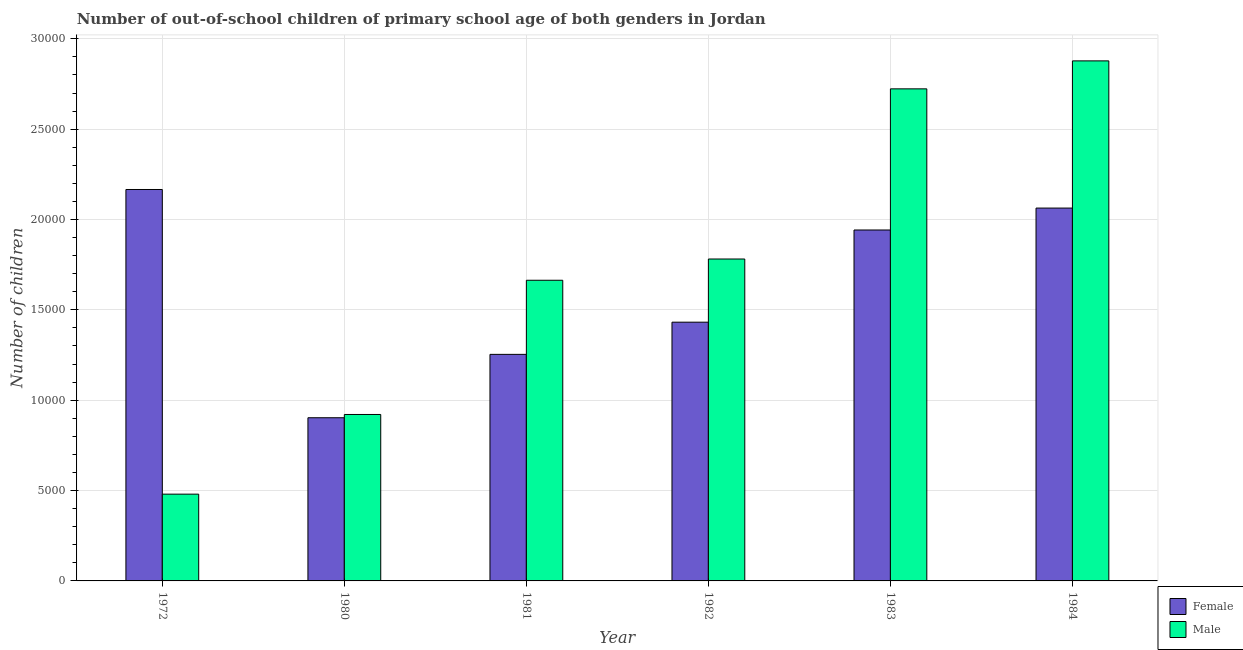How many different coloured bars are there?
Provide a short and direct response. 2. Are the number of bars per tick equal to the number of legend labels?
Your response must be concise. Yes. How many bars are there on the 1st tick from the left?
Offer a very short reply. 2. What is the label of the 5th group of bars from the left?
Your response must be concise. 1983. In how many cases, is the number of bars for a given year not equal to the number of legend labels?
Ensure brevity in your answer.  0. What is the number of female out-of-school students in 1972?
Keep it short and to the point. 2.17e+04. Across all years, what is the maximum number of male out-of-school students?
Provide a succinct answer. 2.88e+04. Across all years, what is the minimum number of female out-of-school students?
Keep it short and to the point. 9030. In which year was the number of female out-of-school students maximum?
Provide a succinct answer. 1972. In which year was the number of male out-of-school students minimum?
Your response must be concise. 1972. What is the total number of male out-of-school students in the graph?
Your response must be concise. 1.04e+05. What is the difference between the number of male out-of-school students in 1982 and that in 1984?
Offer a terse response. -1.10e+04. What is the difference between the number of female out-of-school students in 1982 and the number of male out-of-school students in 1980?
Your answer should be very brief. 5288. What is the average number of female out-of-school students per year?
Give a very brief answer. 1.63e+04. In the year 1981, what is the difference between the number of female out-of-school students and number of male out-of-school students?
Your answer should be compact. 0. What is the ratio of the number of female out-of-school students in 1981 to that in 1982?
Your response must be concise. 0.88. Is the difference between the number of male out-of-school students in 1980 and 1981 greater than the difference between the number of female out-of-school students in 1980 and 1981?
Provide a short and direct response. No. What is the difference between the highest and the second highest number of female out-of-school students?
Keep it short and to the point. 1028. What is the difference between the highest and the lowest number of female out-of-school students?
Provide a short and direct response. 1.26e+04. In how many years, is the number of male out-of-school students greater than the average number of male out-of-school students taken over all years?
Give a very brief answer. 3. Is the sum of the number of male out-of-school students in 1981 and 1982 greater than the maximum number of female out-of-school students across all years?
Provide a short and direct response. Yes. What does the 1st bar from the left in 1980 represents?
Ensure brevity in your answer.  Female. How many bars are there?
Give a very brief answer. 12. What is the difference between two consecutive major ticks on the Y-axis?
Your answer should be compact. 5000. Where does the legend appear in the graph?
Give a very brief answer. Bottom right. How many legend labels are there?
Your response must be concise. 2. What is the title of the graph?
Keep it short and to the point. Number of out-of-school children of primary school age of both genders in Jordan. Does "Short-term debt" appear as one of the legend labels in the graph?
Ensure brevity in your answer.  No. What is the label or title of the X-axis?
Keep it short and to the point. Year. What is the label or title of the Y-axis?
Keep it short and to the point. Number of children. What is the Number of children of Female in 1972?
Your response must be concise. 2.17e+04. What is the Number of children of Male in 1972?
Ensure brevity in your answer.  4802. What is the Number of children of Female in 1980?
Your answer should be very brief. 9030. What is the Number of children in Male in 1980?
Your answer should be very brief. 9211. What is the Number of children in Female in 1981?
Offer a terse response. 1.25e+04. What is the Number of children in Male in 1981?
Offer a terse response. 1.66e+04. What is the Number of children of Female in 1982?
Offer a very short reply. 1.43e+04. What is the Number of children in Male in 1982?
Your answer should be very brief. 1.78e+04. What is the Number of children in Female in 1983?
Keep it short and to the point. 1.94e+04. What is the Number of children in Male in 1983?
Your response must be concise. 2.72e+04. What is the Number of children in Female in 1984?
Your response must be concise. 2.06e+04. What is the Number of children in Male in 1984?
Your answer should be compact. 2.88e+04. Across all years, what is the maximum Number of children of Female?
Ensure brevity in your answer.  2.17e+04. Across all years, what is the maximum Number of children of Male?
Keep it short and to the point. 2.88e+04. Across all years, what is the minimum Number of children in Female?
Ensure brevity in your answer.  9030. Across all years, what is the minimum Number of children of Male?
Give a very brief answer. 4802. What is the total Number of children in Female in the graph?
Ensure brevity in your answer.  9.76e+04. What is the total Number of children in Male in the graph?
Provide a succinct answer. 1.04e+05. What is the difference between the Number of children of Female in 1972 and that in 1980?
Give a very brief answer. 1.26e+04. What is the difference between the Number of children in Male in 1972 and that in 1980?
Keep it short and to the point. -4409. What is the difference between the Number of children in Female in 1972 and that in 1981?
Your response must be concise. 9124. What is the difference between the Number of children of Male in 1972 and that in 1981?
Offer a very short reply. -1.18e+04. What is the difference between the Number of children in Female in 1972 and that in 1982?
Ensure brevity in your answer.  7343. What is the difference between the Number of children of Male in 1972 and that in 1982?
Your response must be concise. -1.30e+04. What is the difference between the Number of children in Female in 1972 and that in 1983?
Your answer should be compact. 2241. What is the difference between the Number of children in Male in 1972 and that in 1983?
Your answer should be very brief. -2.24e+04. What is the difference between the Number of children of Female in 1972 and that in 1984?
Your answer should be compact. 1028. What is the difference between the Number of children of Male in 1972 and that in 1984?
Offer a terse response. -2.40e+04. What is the difference between the Number of children in Female in 1980 and that in 1981?
Offer a terse response. -3507. What is the difference between the Number of children of Male in 1980 and that in 1981?
Offer a very short reply. -7427. What is the difference between the Number of children in Female in 1980 and that in 1982?
Give a very brief answer. -5288. What is the difference between the Number of children in Male in 1980 and that in 1982?
Make the answer very short. -8603. What is the difference between the Number of children of Female in 1980 and that in 1983?
Give a very brief answer. -1.04e+04. What is the difference between the Number of children in Male in 1980 and that in 1983?
Provide a short and direct response. -1.80e+04. What is the difference between the Number of children of Female in 1980 and that in 1984?
Your response must be concise. -1.16e+04. What is the difference between the Number of children in Male in 1980 and that in 1984?
Keep it short and to the point. -1.96e+04. What is the difference between the Number of children of Female in 1981 and that in 1982?
Your answer should be compact. -1781. What is the difference between the Number of children in Male in 1981 and that in 1982?
Make the answer very short. -1176. What is the difference between the Number of children in Female in 1981 and that in 1983?
Offer a terse response. -6883. What is the difference between the Number of children of Male in 1981 and that in 1983?
Offer a terse response. -1.06e+04. What is the difference between the Number of children of Female in 1981 and that in 1984?
Your response must be concise. -8096. What is the difference between the Number of children in Male in 1981 and that in 1984?
Offer a terse response. -1.21e+04. What is the difference between the Number of children in Female in 1982 and that in 1983?
Provide a succinct answer. -5102. What is the difference between the Number of children in Male in 1982 and that in 1983?
Give a very brief answer. -9416. What is the difference between the Number of children in Female in 1982 and that in 1984?
Give a very brief answer. -6315. What is the difference between the Number of children in Male in 1982 and that in 1984?
Offer a terse response. -1.10e+04. What is the difference between the Number of children of Female in 1983 and that in 1984?
Give a very brief answer. -1213. What is the difference between the Number of children of Male in 1983 and that in 1984?
Keep it short and to the point. -1548. What is the difference between the Number of children in Female in 1972 and the Number of children in Male in 1980?
Offer a very short reply. 1.24e+04. What is the difference between the Number of children in Female in 1972 and the Number of children in Male in 1981?
Offer a terse response. 5023. What is the difference between the Number of children of Female in 1972 and the Number of children of Male in 1982?
Offer a very short reply. 3847. What is the difference between the Number of children of Female in 1972 and the Number of children of Male in 1983?
Offer a very short reply. -5569. What is the difference between the Number of children in Female in 1972 and the Number of children in Male in 1984?
Your answer should be very brief. -7117. What is the difference between the Number of children of Female in 1980 and the Number of children of Male in 1981?
Keep it short and to the point. -7608. What is the difference between the Number of children of Female in 1980 and the Number of children of Male in 1982?
Ensure brevity in your answer.  -8784. What is the difference between the Number of children in Female in 1980 and the Number of children in Male in 1983?
Give a very brief answer. -1.82e+04. What is the difference between the Number of children of Female in 1980 and the Number of children of Male in 1984?
Your answer should be very brief. -1.97e+04. What is the difference between the Number of children in Female in 1981 and the Number of children in Male in 1982?
Provide a succinct answer. -5277. What is the difference between the Number of children in Female in 1981 and the Number of children in Male in 1983?
Provide a succinct answer. -1.47e+04. What is the difference between the Number of children in Female in 1981 and the Number of children in Male in 1984?
Give a very brief answer. -1.62e+04. What is the difference between the Number of children in Female in 1982 and the Number of children in Male in 1983?
Your answer should be compact. -1.29e+04. What is the difference between the Number of children of Female in 1982 and the Number of children of Male in 1984?
Your answer should be very brief. -1.45e+04. What is the difference between the Number of children in Female in 1983 and the Number of children in Male in 1984?
Ensure brevity in your answer.  -9358. What is the average Number of children of Female per year?
Your answer should be compact. 1.63e+04. What is the average Number of children in Male per year?
Provide a short and direct response. 1.74e+04. In the year 1972, what is the difference between the Number of children of Female and Number of children of Male?
Provide a short and direct response. 1.69e+04. In the year 1980, what is the difference between the Number of children in Female and Number of children in Male?
Ensure brevity in your answer.  -181. In the year 1981, what is the difference between the Number of children in Female and Number of children in Male?
Provide a succinct answer. -4101. In the year 1982, what is the difference between the Number of children of Female and Number of children of Male?
Provide a succinct answer. -3496. In the year 1983, what is the difference between the Number of children of Female and Number of children of Male?
Provide a succinct answer. -7810. In the year 1984, what is the difference between the Number of children of Female and Number of children of Male?
Ensure brevity in your answer.  -8145. What is the ratio of the Number of children of Female in 1972 to that in 1980?
Provide a succinct answer. 2.4. What is the ratio of the Number of children in Male in 1972 to that in 1980?
Your answer should be very brief. 0.52. What is the ratio of the Number of children in Female in 1972 to that in 1981?
Provide a short and direct response. 1.73. What is the ratio of the Number of children of Male in 1972 to that in 1981?
Your response must be concise. 0.29. What is the ratio of the Number of children in Female in 1972 to that in 1982?
Keep it short and to the point. 1.51. What is the ratio of the Number of children in Male in 1972 to that in 1982?
Ensure brevity in your answer.  0.27. What is the ratio of the Number of children of Female in 1972 to that in 1983?
Offer a very short reply. 1.12. What is the ratio of the Number of children of Male in 1972 to that in 1983?
Offer a terse response. 0.18. What is the ratio of the Number of children in Female in 1972 to that in 1984?
Offer a very short reply. 1.05. What is the ratio of the Number of children in Male in 1972 to that in 1984?
Keep it short and to the point. 0.17. What is the ratio of the Number of children in Female in 1980 to that in 1981?
Your answer should be compact. 0.72. What is the ratio of the Number of children in Male in 1980 to that in 1981?
Make the answer very short. 0.55. What is the ratio of the Number of children of Female in 1980 to that in 1982?
Provide a succinct answer. 0.63. What is the ratio of the Number of children in Male in 1980 to that in 1982?
Your answer should be compact. 0.52. What is the ratio of the Number of children of Female in 1980 to that in 1983?
Provide a short and direct response. 0.47. What is the ratio of the Number of children of Male in 1980 to that in 1983?
Offer a very short reply. 0.34. What is the ratio of the Number of children of Female in 1980 to that in 1984?
Your answer should be compact. 0.44. What is the ratio of the Number of children of Male in 1980 to that in 1984?
Make the answer very short. 0.32. What is the ratio of the Number of children of Female in 1981 to that in 1982?
Keep it short and to the point. 0.88. What is the ratio of the Number of children of Male in 1981 to that in 1982?
Keep it short and to the point. 0.93. What is the ratio of the Number of children of Female in 1981 to that in 1983?
Your answer should be very brief. 0.65. What is the ratio of the Number of children of Male in 1981 to that in 1983?
Keep it short and to the point. 0.61. What is the ratio of the Number of children in Female in 1981 to that in 1984?
Provide a short and direct response. 0.61. What is the ratio of the Number of children in Male in 1981 to that in 1984?
Offer a very short reply. 0.58. What is the ratio of the Number of children in Female in 1982 to that in 1983?
Provide a short and direct response. 0.74. What is the ratio of the Number of children in Male in 1982 to that in 1983?
Provide a short and direct response. 0.65. What is the ratio of the Number of children of Female in 1982 to that in 1984?
Offer a very short reply. 0.69. What is the ratio of the Number of children of Male in 1982 to that in 1984?
Keep it short and to the point. 0.62. What is the ratio of the Number of children in Male in 1983 to that in 1984?
Ensure brevity in your answer.  0.95. What is the difference between the highest and the second highest Number of children in Female?
Make the answer very short. 1028. What is the difference between the highest and the second highest Number of children in Male?
Ensure brevity in your answer.  1548. What is the difference between the highest and the lowest Number of children in Female?
Your response must be concise. 1.26e+04. What is the difference between the highest and the lowest Number of children of Male?
Keep it short and to the point. 2.40e+04. 